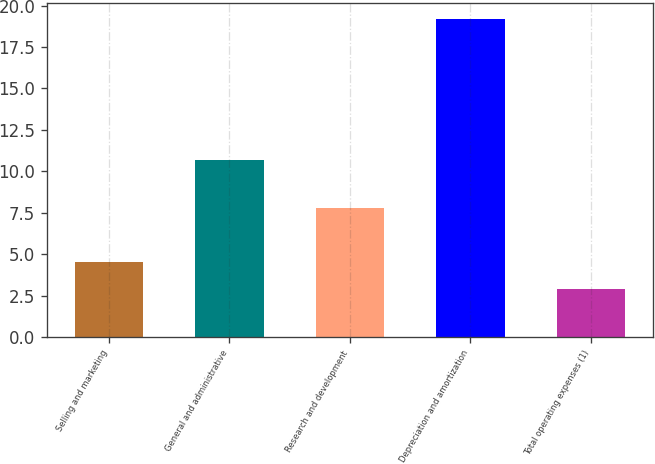Convert chart to OTSL. <chart><loc_0><loc_0><loc_500><loc_500><bar_chart><fcel>Selling and marketing<fcel>General and administrative<fcel>Research and development<fcel>Depreciation and amortization<fcel>Total operating expenses (1)<nl><fcel>4.53<fcel>10.7<fcel>7.8<fcel>19.2<fcel>2.9<nl></chart> 